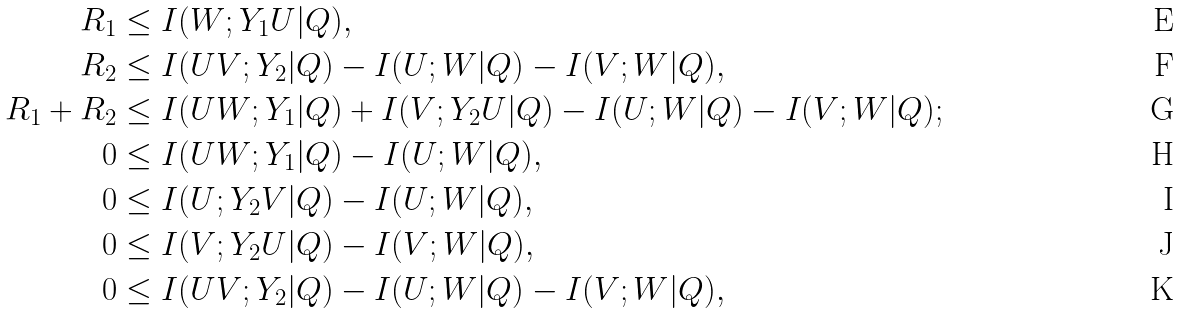Convert formula to latex. <formula><loc_0><loc_0><loc_500><loc_500>R _ { 1 } & \leq I ( W ; Y _ { 1 } U | Q ) , \\ R _ { 2 } & \leq I ( U V ; Y _ { 2 } | Q ) - I ( U ; W | Q ) - I ( V ; W | Q ) , \\ R _ { 1 } + R _ { 2 } & \leq I ( U W ; Y _ { 1 } | Q ) + I ( V ; Y _ { 2 } U | Q ) - I ( U ; W | Q ) - I ( V ; W | Q ) ; \\ 0 & \leq I ( U W ; Y _ { 1 } | Q ) - I ( U ; W | Q ) , \\ 0 & \leq I ( U ; Y _ { 2 } V | Q ) - I ( U ; W | Q ) , \\ 0 & \leq I ( V ; Y _ { 2 } U | Q ) - I ( V ; W | Q ) , \\ 0 & \leq I ( U V ; Y _ { 2 } | Q ) - I ( U ; W | Q ) - I ( V ; W | Q ) ,</formula> 